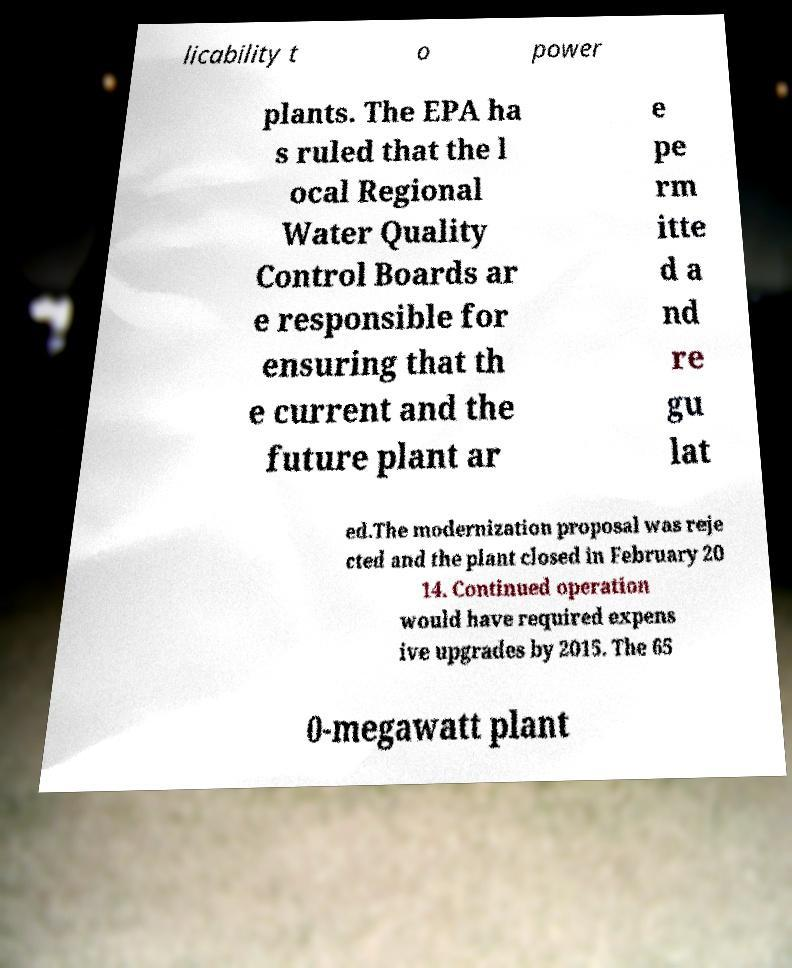Could you assist in decoding the text presented in this image and type it out clearly? licability t o power plants. The EPA ha s ruled that the l ocal Regional Water Quality Control Boards ar e responsible for ensuring that th e current and the future plant ar e pe rm itte d a nd re gu lat ed.The modernization proposal was reje cted and the plant closed in February 20 14. Continued operation would have required expens ive upgrades by 2015. The 65 0-megawatt plant 